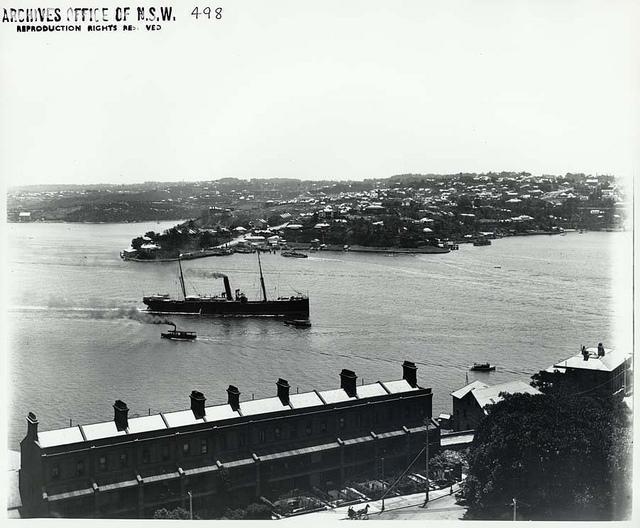How many cars are in front of the motorcycle?
Give a very brief answer. 0. 